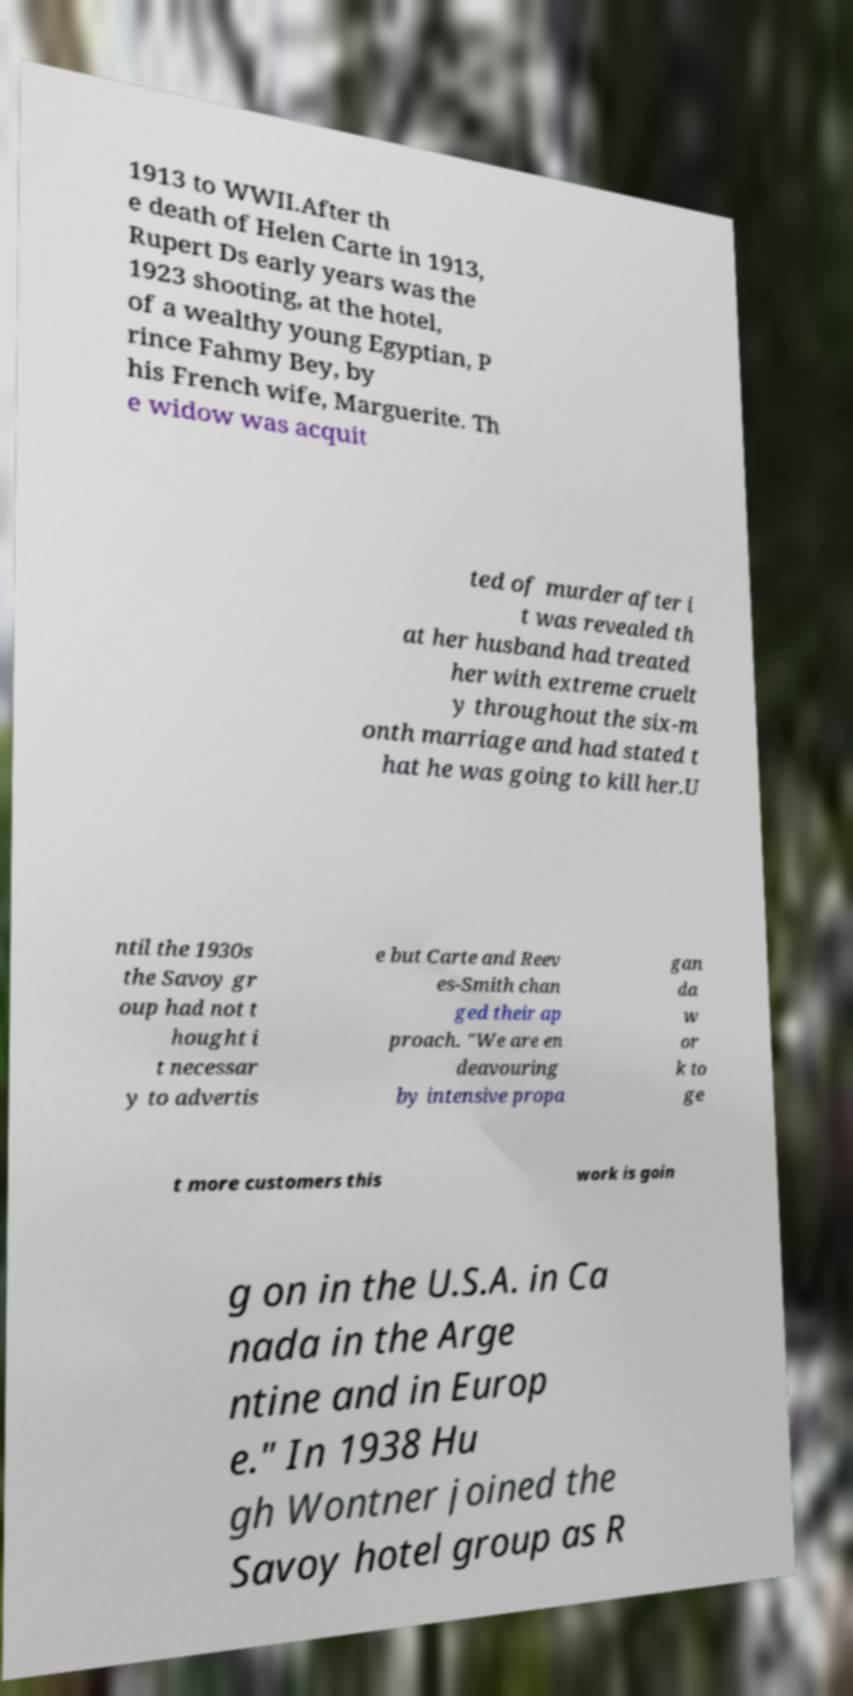For documentation purposes, I need the text within this image transcribed. Could you provide that? 1913 to WWII.After th e death of Helen Carte in 1913, Rupert Ds early years was the 1923 shooting, at the hotel, of a wealthy young Egyptian, P rince Fahmy Bey, by his French wife, Marguerite. Th e widow was acquit ted of murder after i t was revealed th at her husband had treated her with extreme cruelt y throughout the six-m onth marriage and had stated t hat he was going to kill her.U ntil the 1930s the Savoy gr oup had not t hought i t necessar y to advertis e but Carte and Reev es-Smith chan ged their ap proach. "We are en deavouring by intensive propa gan da w or k to ge t more customers this work is goin g on in the U.S.A. in Ca nada in the Arge ntine and in Europ e." In 1938 Hu gh Wontner joined the Savoy hotel group as R 